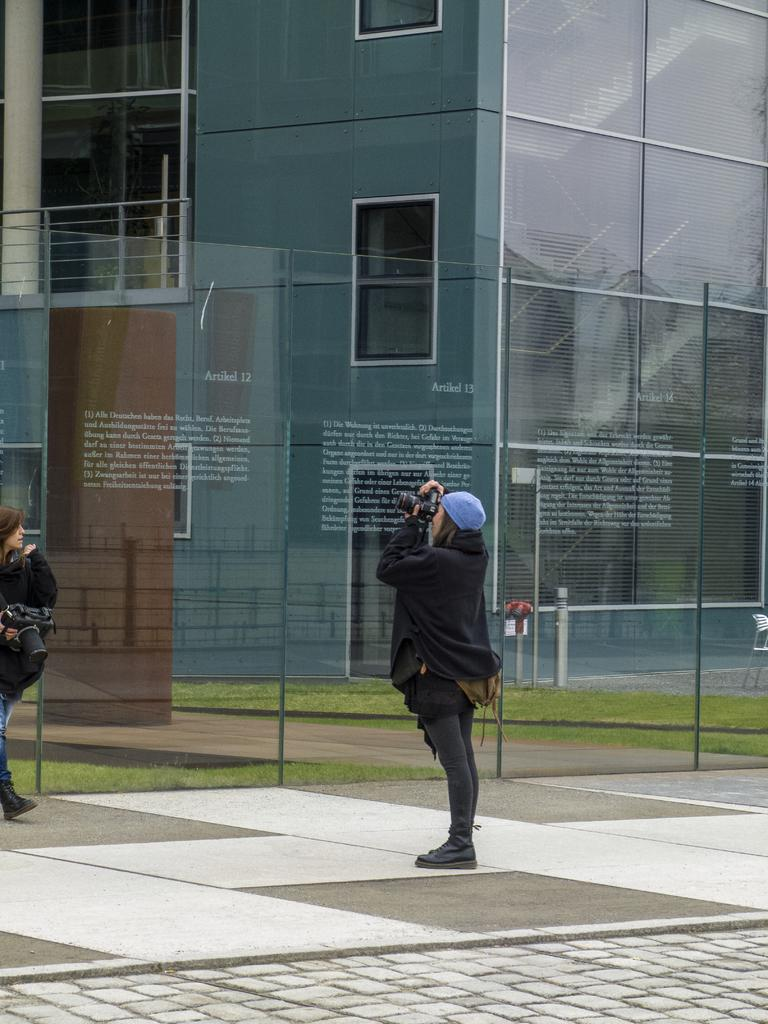Who is present in the image? There is a woman in the image. What is the woman holding in the image? The woman is holding a camera. What can be seen in the background of the image? There is a building in the image. What feature of the building is mentioned in the facts? The building has windows. What type of trousers is the woman wearing in the image? The facts provided do not mention the type of trousers the woman is wearing, so we cannot determine that information from the image. Can you hear the sound of a horn in the image? There is no mention of a horn or any sound in the image, so we cannot determine if a horn is present or if a sound can be heard. 